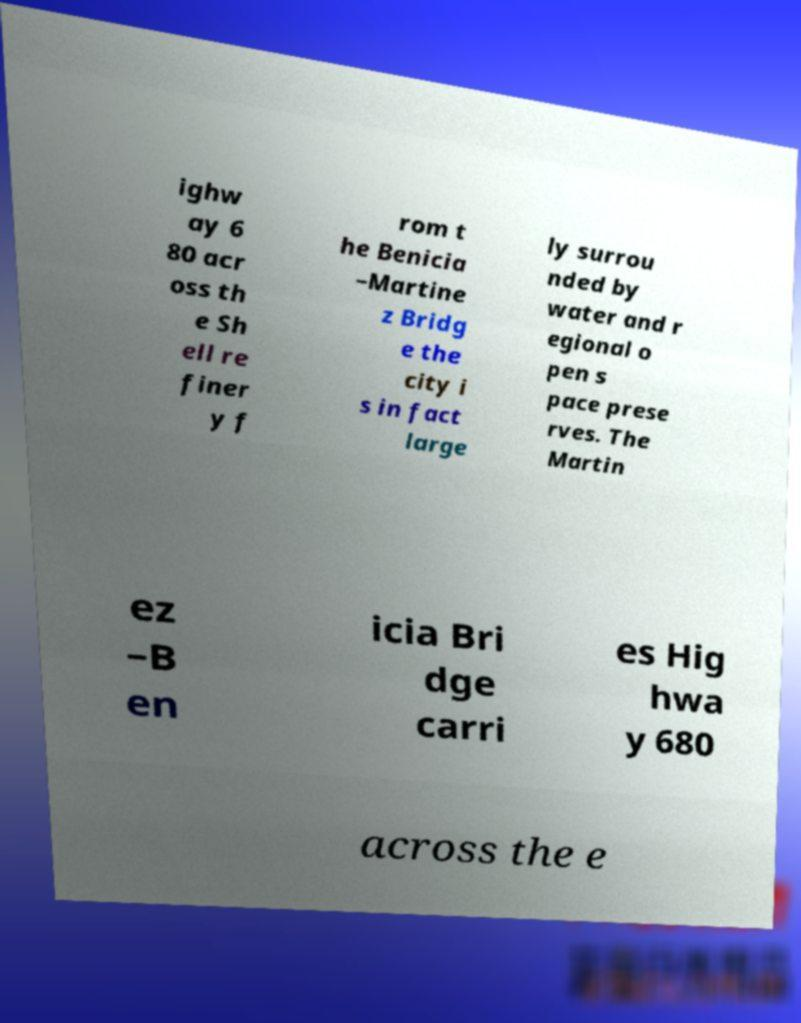There's text embedded in this image that I need extracted. Can you transcribe it verbatim? ighw ay 6 80 acr oss th e Sh ell re finer y f rom t he Benicia –Martine z Bridg e the city i s in fact large ly surrou nded by water and r egional o pen s pace prese rves. The Martin ez –B en icia Bri dge carri es Hig hwa y 680 across the e 